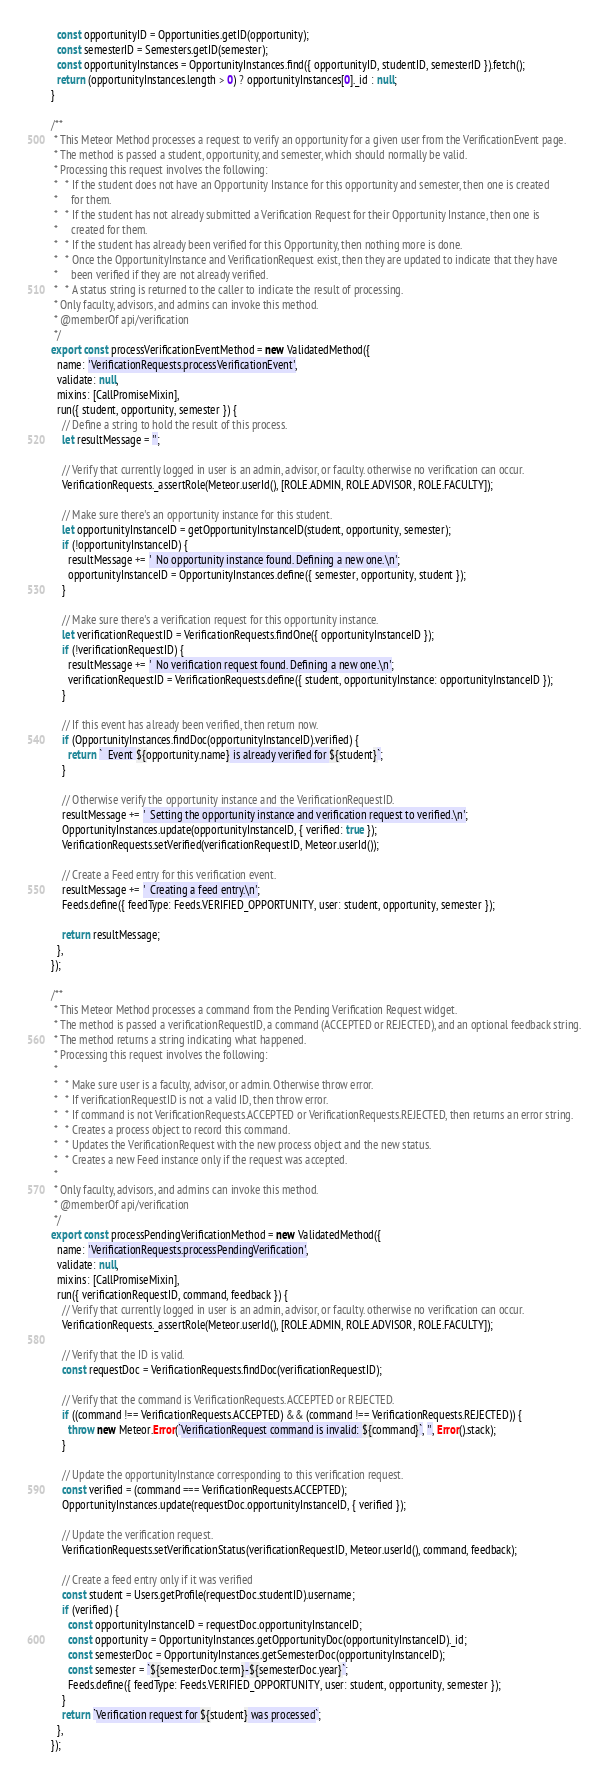<code> <loc_0><loc_0><loc_500><loc_500><_JavaScript_>  const opportunityID = Opportunities.getID(opportunity);
  const semesterID = Semesters.getID(semester);
  const opportunityInstances = OpportunityInstances.find({ opportunityID, studentID, semesterID }).fetch();
  return (opportunityInstances.length > 0) ? opportunityInstances[0]._id : null;
}

/**
 * This Meteor Method processes a request to verify an opportunity for a given user from the VerificationEvent page.
 * The method is passed a student, opportunity, and semester, which should normally be valid.
 * Processing this request involves the following:
 *   * If the student does not have an Opportunity Instance for this opportunity and semester, then one is created
 *     for them.
 *   * If the student has not already submitted a Verification Request for their Opportunity Instance, then one is
 *     created for them.
 *   * If the student has already been verified for this Opportunity, then nothing more is done.
 *   * Once the OpportunityInstance and VerificationRequest exist, then they are updated to indicate that they have
 *     been verified if they are not already verified.
 *   * A status string is returned to the caller to indicate the result of processing.
 * Only faculty, advisors, and admins can invoke this method.
 * @memberOf api/verification
 */
export const processVerificationEventMethod = new ValidatedMethod({
  name: 'VerificationRequests.processVerificationEvent',
  validate: null,
  mixins: [CallPromiseMixin],
  run({ student, opportunity, semester }) {
    // Define a string to hold the result of this process.
    let resultMessage = '';

    // Verify that currently logged in user is an admin, advisor, or faculty. otherwise no verification can occur.
    VerificationRequests._assertRole(Meteor.userId(), [ROLE.ADMIN, ROLE.ADVISOR, ROLE.FACULTY]);

    // Make sure there's an opportunity instance for this student.
    let opportunityInstanceID = getOpportunityInstanceID(student, opportunity, semester);
    if (!opportunityInstanceID) {
      resultMessage += '  No opportunity instance found. Defining a new one.\n';
      opportunityInstanceID = OpportunityInstances.define({ semester, opportunity, student });
    }

    // Make sure there's a verification request for this opportunity instance.
    let verificationRequestID = VerificationRequests.findOne({ opportunityInstanceID });
    if (!verificationRequestID) {
      resultMessage += '  No verification request found. Defining a new one.\n';
      verificationRequestID = VerificationRequests.define({ student, opportunityInstance: opportunityInstanceID });
    }

    // If this event has already been verified, then return now.
    if (OpportunityInstances.findDoc(opportunityInstanceID).verified) {
      return `  Event ${opportunity.name} is already verified for ${student}`;
    }

    // Otherwise verify the opportunity instance and the VerificationRequestID.
    resultMessage += '  Setting the opportunity instance and verification request to verified.\n';
    OpportunityInstances.update(opportunityInstanceID, { verified: true });
    VerificationRequests.setVerified(verificationRequestID, Meteor.userId());

    // Create a Feed entry for this verification event.
    resultMessage += '  Creating a feed entry.\n';
    Feeds.define({ feedType: Feeds.VERIFIED_OPPORTUNITY, user: student, opportunity, semester });

    return resultMessage;
  },
});

/**
 * This Meteor Method processes a command from the Pending Verification Request widget.
 * The method is passed a verificationRequestID, a command (ACCEPTED or REJECTED), and an optional feedback string.
 * The method returns a string indicating what happened.
 * Processing this request involves the following:
 *
 *   * Make sure user is a faculty, advisor, or admin. Otherwise throw error.
 *   * If verificationRequestID is not a valid ID, then throw error.
 *   * If command is not VerificationRequests.ACCEPTED or VerificationRequests.REJECTED, then returns an error string.
 *   * Creates a process object to record this command.
 *   * Updates the VerificationRequest with the new process object and the new status.
 *   * Creates a new Feed instance only if the request was accepted.
 *
 * Only faculty, advisors, and admins can invoke this method.
 * @memberOf api/verification
 */
export const processPendingVerificationMethod = new ValidatedMethod({
  name: 'VerificationRequests.processPendingVerification',
  validate: null,
  mixins: [CallPromiseMixin],
  run({ verificationRequestID, command, feedback }) {
    // Verify that currently logged in user is an admin, advisor, or faculty. otherwise no verification can occur.
    VerificationRequests._assertRole(Meteor.userId(), [ROLE.ADMIN, ROLE.ADVISOR, ROLE.FACULTY]);

    // Verify that the ID is valid.
    const requestDoc = VerificationRequests.findDoc(verificationRequestID);

    // Verify that the command is VerificationRequests.ACCEPTED or REJECTED.
    if ((command !== VerificationRequests.ACCEPTED) && (command !== VerificationRequests.REJECTED)) {
      throw new Meteor.Error(`VerificationRequest command is invalid: ${command}`, '', Error().stack);
    }

    // Update the opportunityInstance corresponding to this verification request.
    const verified = (command === VerificationRequests.ACCEPTED);
    OpportunityInstances.update(requestDoc.opportunityInstanceID, { verified });

    // Update the verification request.
    VerificationRequests.setVerificationStatus(verificationRequestID, Meteor.userId(), command, feedback);

    // Create a feed entry only if it was verified
    const student = Users.getProfile(requestDoc.studentID).username;
    if (verified) {
      const opportunityInstanceID = requestDoc.opportunityInstanceID;
      const opportunity = OpportunityInstances.getOpportunityDoc(opportunityInstanceID)._id;
      const semesterDoc = OpportunityInstances.getSemesterDoc(opportunityInstanceID);
      const semester = `${semesterDoc.term}-${semesterDoc.year}`;
      Feeds.define({ feedType: Feeds.VERIFIED_OPPORTUNITY, user: student, opportunity, semester });
    }
    return `Verification request for ${student} was processed`;
  },
});
</code> 